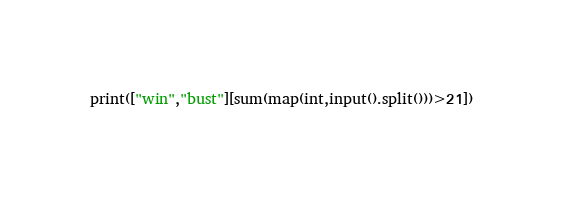<code> <loc_0><loc_0><loc_500><loc_500><_Python_>print(["win","bust"][sum(map(int,input().split()))>21])</code> 